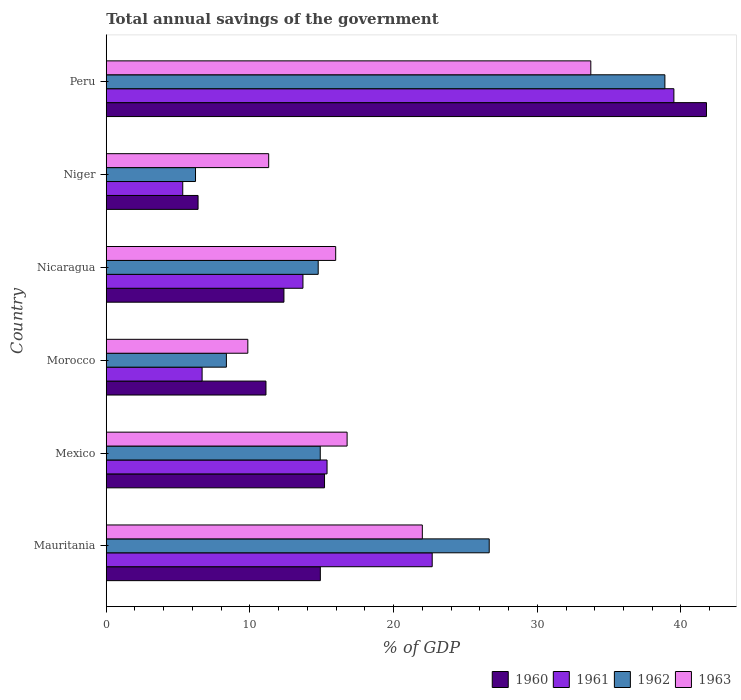Are the number of bars per tick equal to the number of legend labels?
Your response must be concise. Yes. Are the number of bars on each tick of the Y-axis equal?
Provide a short and direct response. Yes. How many bars are there on the 4th tick from the top?
Provide a succinct answer. 4. How many bars are there on the 6th tick from the bottom?
Ensure brevity in your answer.  4. What is the label of the 3rd group of bars from the top?
Offer a very short reply. Nicaragua. What is the total annual savings of the government in 1962 in Niger?
Provide a short and direct response. 6.21. Across all countries, what is the maximum total annual savings of the government in 1960?
Provide a succinct answer. 41.78. Across all countries, what is the minimum total annual savings of the government in 1960?
Provide a short and direct response. 6.39. In which country was the total annual savings of the government in 1963 maximum?
Make the answer very short. Peru. In which country was the total annual savings of the government in 1961 minimum?
Your answer should be very brief. Niger. What is the total total annual savings of the government in 1962 in the graph?
Offer a terse response. 109.76. What is the difference between the total annual savings of the government in 1961 in Morocco and that in Nicaragua?
Your answer should be very brief. -7.02. What is the difference between the total annual savings of the government in 1960 in Niger and the total annual savings of the government in 1963 in Mexico?
Offer a very short reply. -10.37. What is the average total annual savings of the government in 1961 per country?
Provide a succinct answer. 17.21. What is the difference between the total annual savings of the government in 1962 and total annual savings of the government in 1961 in Mexico?
Provide a short and direct response. -0.47. What is the ratio of the total annual savings of the government in 1961 in Mauritania to that in Peru?
Your response must be concise. 0.57. Is the difference between the total annual savings of the government in 1962 in Niger and Peru greater than the difference between the total annual savings of the government in 1961 in Niger and Peru?
Provide a succinct answer. Yes. What is the difference between the highest and the second highest total annual savings of the government in 1963?
Offer a very short reply. 11.73. What is the difference between the highest and the lowest total annual savings of the government in 1960?
Your response must be concise. 35.38. In how many countries, is the total annual savings of the government in 1962 greater than the average total annual savings of the government in 1962 taken over all countries?
Offer a very short reply. 2. Is it the case that in every country, the sum of the total annual savings of the government in 1960 and total annual savings of the government in 1963 is greater than the sum of total annual savings of the government in 1961 and total annual savings of the government in 1962?
Offer a terse response. No. What does the 1st bar from the top in Mexico represents?
Your answer should be very brief. 1963. What does the 2nd bar from the bottom in Peru represents?
Offer a terse response. 1961. Are all the bars in the graph horizontal?
Give a very brief answer. Yes. What is the difference between two consecutive major ticks on the X-axis?
Provide a short and direct response. 10. Are the values on the major ticks of X-axis written in scientific E-notation?
Your answer should be compact. No. Does the graph contain grids?
Make the answer very short. No. How many legend labels are there?
Offer a very short reply. 4. What is the title of the graph?
Offer a terse response. Total annual savings of the government. What is the label or title of the X-axis?
Offer a terse response. % of GDP. What is the % of GDP in 1960 in Mauritania?
Provide a succinct answer. 14.9. What is the % of GDP of 1961 in Mauritania?
Offer a terse response. 22.69. What is the % of GDP in 1962 in Mauritania?
Ensure brevity in your answer.  26.65. What is the % of GDP in 1963 in Mauritania?
Offer a terse response. 22. What is the % of GDP of 1960 in Mexico?
Ensure brevity in your answer.  15.19. What is the % of GDP of 1961 in Mexico?
Your response must be concise. 15.37. What is the % of GDP in 1962 in Mexico?
Give a very brief answer. 14.89. What is the % of GDP in 1963 in Mexico?
Your answer should be very brief. 16.76. What is the % of GDP in 1960 in Morocco?
Offer a terse response. 11.12. What is the % of GDP in 1961 in Morocco?
Your response must be concise. 6.67. What is the % of GDP in 1962 in Morocco?
Give a very brief answer. 8.36. What is the % of GDP in 1963 in Morocco?
Your answer should be compact. 9.85. What is the % of GDP in 1960 in Nicaragua?
Provide a succinct answer. 12.37. What is the % of GDP in 1961 in Nicaragua?
Your answer should be compact. 13.69. What is the % of GDP of 1962 in Nicaragua?
Offer a terse response. 14.75. What is the % of GDP of 1963 in Nicaragua?
Keep it short and to the point. 15.97. What is the % of GDP in 1960 in Niger?
Ensure brevity in your answer.  6.39. What is the % of GDP in 1961 in Niger?
Your answer should be very brief. 5.32. What is the % of GDP of 1962 in Niger?
Your answer should be compact. 6.21. What is the % of GDP of 1963 in Niger?
Keep it short and to the point. 11.31. What is the % of GDP of 1960 in Peru?
Your answer should be compact. 41.78. What is the % of GDP in 1961 in Peru?
Offer a terse response. 39.51. What is the % of GDP in 1962 in Peru?
Provide a short and direct response. 38.88. What is the % of GDP of 1963 in Peru?
Give a very brief answer. 33.73. Across all countries, what is the maximum % of GDP in 1960?
Offer a terse response. 41.78. Across all countries, what is the maximum % of GDP of 1961?
Your answer should be very brief. 39.51. Across all countries, what is the maximum % of GDP of 1962?
Give a very brief answer. 38.88. Across all countries, what is the maximum % of GDP of 1963?
Your response must be concise. 33.73. Across all countries, what is the minimum % of GDP of 1960?
Provide a short and direct response. 6.39. Across all countries, what is the minimum % of GDP of 1961?
Your response must be concise. 5.32. Across all countries, what is the minimum % of GDP of 1962?
Offer a very short reply. 6.21. Across all countries, what is the minimum % of GDP of 1963?
Ensure brevity in your answer.  9.85. What is the total % of GDP in 1960 in the graph?
Provide a short and direct response. 101.74. What is the total % of GDP in 1961 in the graph?
Your answer should be very brief. 103.25. What is the total % of GDP in 1962 in the graph?
Give a very brief answer. 109.76. What is the total % of GDP of 1963 in the graph?
Make the answer very short. 109.62. What is the difference between the % of GDP in 1960 in Mauritania and that in Mexico?
Offer a very short reply. -0.29. What is the difference between the % of GDP of 1961 in Mauritania and that in Mexico?
Your answer should be compact. 7.32. What is the difference between the % of GDP of 1962 in Mauritania and that in Mexico?
Keep it short and to the point. 11.76. What is the difference between the % of GDP in 1963 in Mauritania and that in Mexico?
Your response must be concise. 5.24. What is the difference between the % of GDP of 1960 in Mauritania and that in Morocco?
Your response must be concise. 3.78. What is the difference between the % of GDP of 1961 in Mauritania and that in Morocco?
Give a very brief answer. 16.02. What is the difference between the % of GDP in 1962 in Mauritania and that in Morocco?
Your answer should be very brief. 18.29. What is the difference between the % of GDP of 1963 in Mauritania and that in Morocco?
Keep it short and to the point. 12.14. What is the difference between the % of GDP of 1960 in Mauritania and that in Nicaragua?
Make the answer very short. 2.53. What is the difference between the % of GDP in 1961 in Mauritania and that in Nicaragua?
Make the answer very short. 9. What is the difference between the % of GDP of 1962 in Mauritania and that in Nicaragua?
Your answer should be very brief. 11.9. What is the difference between the % of GDP of 1963 in Mauritania and that in Nicaragua?
Give a very brief answer. 6.03. What is the difference between the % of GDP in 1960 in Mauritania and that in Niger?
Your answer should be compact. 8.51. What is the difference between the % of GDP in 1961 in Mauritania and that in Niger?
Ensure brevity in your answer.  17.36. What is the difference between the % of GDP of 1962 in Mauritania and that in Niger?
Offer a very short reply. 20.44. What is the difference between the % of GDP of 1963 in Mauritania and that in Niger?
Ensure brevity in your answer.  10.69. What is the difference between the % of GDP of 1960 in Mauritania and that in Peru?
Provide a succinct answer. -26.88. What is the difference between the % of GDP of 1961 in Mauritania and that in Peru?
Provide a succinct answer. -16.82. What is the difference between the % of GDP in 1962 in Mauritania and that in Peru?
Provide a succinct answer. -12.23. What is the difference between the % of GDP in 1963 in Mauritania and that in Peru?
Your response must be concise. -11.73. What is the difference between the % of GDP in 1960 in Mexico and that in Morocco?
Your response must be concise. 4.08. What is the difference between the % of GDP in 1961 in Mexico and that in Morocco?
Offer a terse response. 8.7. What is the difference between the % of GDP of 1962 in Mexico and that in Morocco?
Provide a succinct answer. 6.53. What is the difference between the % of GDP of 1963 in Mexico and that in Morocco?
Offer a terse response. 6.91. What is the difference between the % of GDP in 1960 in Mexico and that in Nicaragua?
Provide a short and direct response. 2.82. What is the difference between the % of GDP of 1961 in Mexico and that in Nicaragua?
Make the answer very short. 1.68. What is the difference between the % of GDP in 1962 in Mexico and that in Nicaragua?
Keep it short and to the point. 0.14. What is the difference between the % of GDP in 1963 in Mexico and that in Nicaragua?
Make the answer very short. 0.8. What is the difference between the % of GDP of 1960 in Mexico and that in Niger?
Provide a short and direct response. 8.8. What is the difference between the % of GDP of 1961 in Mexico and that in Niger?
Make the answer very short. 10.04. What is the difference between the % of GDP of 1962 in Mexico and that in Niger?
Give a very brief answer. 8.68. What is the difference between the % of GDP in 1963 in Mexico and that in Niger?
Your answer should be very brief. 5.46. What is the difference between the % of GDP in 1960 in Mexico and that in Peru?
Give a very brief answer. -26.58. What is the difference between the % of GDP in 1961 in Mexico and that in Peru?
Provide a succinct answer. -24.14. What is the difference between the % of GDP of 1962 in Mexico and that in Peru?
Your response must be concise. -23.99. What is the difference between the % of GDP in 1963 in Mexico and that in Peru?
Provide a short and direct response. -16.96. What is the difference between the % of GDP of 1960 in Morocco and that in Nicaragua?
Your answer should be very brief. -1.25. What is the difference between the % of GDP in 1961 in Morocco and that in Nicaragua?
Your response must be concise. -7.02. What is the difference between the % of GDP of 1962 in Morocco and that in Nicaragua?
Your answer should be very brief. -6.39. What is the difference between the % of GDP in 1963 in Morocco and that in Nicaragua?
Keep it short and to the point. -6.11. What is the difference between the % of GDP in 1960 in Morocco and that in Niger?
Make the answer very short. 4.73. What is the difference between the % of GDP of 1961 in Morocco and that in Niger?
Make the answer very short. 1.35. What is the difference between the % of GDP in 1962 in Morocco and that in Niger?
Offer a very short reply. 2.15. What is the difference between the % of GDP in 1963 in Morocco and that in Niger?
Ensure brevity in your answer.  -1.45. What is the difference between the % of GDP of 1960 in Morocco and that in Peru?
Your response must be concise. -30.66. What is the difference between the % of GDP in 1961 in Morocco and that in Peru?
Your answer should be very brief. -32.84. What is the difference between the % of GDP of 1962 in Morocco and that in Peru?
Provide a short and direct response. -30.52. What is the difference between the % of GDP in 1963 in Morocco and that in Peru?
Make the answer very short. -23.87. What is the difference between the % of GDP in 1960 in Nicaragua and that in Niger?
Ensure brevity in your answer.  5.98. What is the difference between the % of GDP of 1961 in Nicaragua and that in Niger?
Make the answer very short. 8.37. What is the difference between the % of GDP in 1962 in Nicaragua and that in Niger?
Make the answer very short. 8.54. What is the difference between the % of GDP in 1963 in Nicaragua and that in Niger?
Ensure brevity in your answer.  4.66. What is the difference between the % of GDP in 1960 in Nicaragua and that in Peru?
Make the answer very short. -29.41. What is the difference between the % of GDP in 1961 in Nicaragua and that in Peru?
Provide a short and direct response. -25.82. What is the difference between the % of GDP in 1962 in Nicaragua and that in Peru?
Give a very brief answer. -24.13. What is the difference between the % of GDP in 1963 in Nicaragua and that in Peru?
Offer a very short reply. -17.76. What is the difference between the % of GDP of 1960 in Niger and that in Peru?
Provide a short and direct response. -35.38. What is the difference between the % of GDP in 1961 in Niger and that in Peru?
Offer a terse response. -34.18. What is the difference between the % of GDP of 1962 in Niger and that in Peru?
Your answer should be compact. -32.67. What is the difference between the % of GDP in 1963 in Niger and that in Peru?
Your answer should be compact. -22.42. What is the difference between the % of GDP in 1960 in Mauritania and the % of GDP in 1961 in Mexico?
Keep it short and to the point. -0.47. What is the difference between the % of GDP in 1960 in Mauritania and the % of GDP in 1962 in Mexico?
Offer a very short reply. 0.01. What is the difference between the % of GDP in 1960 in Mauritania and the % of GDP in 1963 in Mexico?
Ensure brevity in your answer.  -1.86. What is the difference between the % of GDP of 1961 in Mauritania and the % of GDP of 1962 in Mexico?
Ensure brevity in your answer.  7.79. What is the difference between the % of GDP of 1961 in Mauritania and the % of GDP of 1963 in Mexico?
Ensure brevity in your answer.  5.92. What is the difference between the % of GDP in 1962 in Mauritania and the % of GDP in 1963 in Mexico?
Provide a short and direct response. 9.89. What is the difference between the % of GDP in 1960 in Mauritania and the % of GDP in 1961 in Morocco?
Ensure brevity in your answer.  8.23. What is the difference between the % of GDP in 1960 in Mauritania and the % of GDP in 1962 in Morocco?
Your response must be concise. 6.54. What is the difference between the % of GDP in 1960 in Mauritania and the % of GDP in 1963 in Morocco?
Your answer should be very brief. 5.05. What is the difference between the % of GDP of 1961 in Mauritania and the % of GDP of 1962 in Morocco?
Your response must be concise. 14.32. What is the difference between the % of GDP in 1961 in Mauritania and the % of GDP in 1963 in Morocco?
Provide a short and direct response. 12.83. What is the difference between the % of GDP in 1962 in Mauritania and the % of GDP in 1963 in Morocco?
Offer a terse response. 16.8. What is the difference between the % of GDP of 1960 in Mauritania and the % of GDP of 1961 in Nicaragua?
Keep it short and to the point. 1.21. What is the difference between the % of GDP of 1960 in Mauritania and the % of GDP of 1962 in Nicaragua?
Give a very brief answer. 0.15. What is the difference between the % of GDP in 1960 in Mauritania and the % of GDP in 1963 in Nicaragua?
Keep it short and to the point. -1.07. What is the difference between the % of GDP of 1961 in Mauritania and the % of GDP of 1962 in Nicaragua?
Give a very brief answer. 7.93. What is the difference between the % of GDP in 1961 in Mauritania and the % of GDP in 1963 in Nicaragua?
Your response must be concise. 6.72. What is the difference between the % of GDP of 1962 in Mauritania and the % of GDP of 1963 in Nicaragua?
Give a very brief answer. 10.69. What is the difference between the % of GDP of 1960 in Mauritania and the % of GDP of 1961 in Niger?
Provide a succinct answer. 9.58. What is the difference between the % of GDP in 1960 in Mauritania and the % of GDP in 1962 in Niger?
Provide a succinct answer. 8.69. What is the difference between the % of GDP in 1960 in Mauritania and the % of GDP in 1963 in Niger?
Offer a very short reply. 3.6. What is the difference between the % of GDP of 1961 in Mauritania and the % of GDP of 1962 in Niger?
Your answer should be very brief. 16.47. What is the difference between the % of GDP of 1961 in Mauritania and the % of GDP of 1963 in Niger?
Offer a very short reply. 11.38. What is the difference between the % of GDP of 1962 in Mauritania and the % of GDP of 1963 in Niger?
Offer a very short reply. 15.35. What is the difference between the % of GDP of 1960 in Mauritania and the % of GDP of 1961 in Peru?
Your answer should be compact. -24.61. What is the difference between the % of GDP of 1960 in Mauritania and the % of GDP of 1962 in Peru?
Your answer should be compact. -23.98. What is the difference between the % of GDP of 1960 in Mauritania and the % of GDP of 1963 in Peru?
Make the answer very short. -18.83. What is the difference between the % of GDP in 1961 in Mauritania and the % of GDP in 1962 in Peru?
Your answer should be compact. -16.19. What is the difference between the % of GDP of 1961 in Mauritania and the % of GDP of 1963 in Peru?
Your answer should be very brief. -11.04. What is the difference between the % of GDP in 1962 in Mauritania and the % of GDP in 1963 in Peru?
Offer a very short reply. -7.07. What is the difference between the % of GDP of 1960 in Mexico and the % of GDP of 1961 in Morocco?
Keep it short and to the point. 8.52. What is the difference between the % of GDP in 1960 in Mexico and the % of GDP in 1962 in Morocco?
Offer a very short reply. 6.83. What is the difference between the % of GDP in 1960 in Mexico and the % of GDP in 1963 in Morocco?
Offer a very short reply. 5.34. What is the difference between the % of GDP of 1961 in Mexico and the % of GDP of 1962 in Morocco?
Your response must be concise. 7.01. What is the difference between the % of GDP in 1961 in Mexico and the % of GDP in 1963 in Morocco?
Your answer should be very brief. 5.51. What is the difference between the % of GDP of 1962 in Mexico and the % of GDP of 1963 in Morocco?
Your answer should be very brief. 5.04. What is the difference between the % of GDP in 1960 in Mexico and the % of GDP in 1961 in Nicaragua?
Provide a succinct answer. 1.5. What is the difference between the % of GDP in 1960 in Mexico and the % of GDP in 1962 in Nicaragua?
Provide a short and direct response. 0.44. What is the difference between the % of GDP of 1960 in Mexico and the % of GDP of 1963 in Nicaragua?
Ensure brevity in your answer.  -0.78. What is the difference between the % of GDP in 1961 in Mexico and the % of GDP in 1962 in Nicaragua?
Keep it short and to the point. 0.62. What is the difference between the % of GDP of 1961 in Mexico and the % of GDP of 1963 in Nicaragua?
Your response must be concise. -0.6. What is the difference between the % of GDP of 1962 in Mexico and the % of GDP of 1963 in Nicaragua?
Your response must be concise. -1.07. What is the difference between the % of GDP in 1960 in Mexico and the % of GDP in 1961 in Niger?
Your answer should be compact. 9.87. What is the difference between the % of GDP of 1960 in Mexico and the % of GDP of 1962 in Niger?
Give a very brief answer. 8.98. What is the difference between the % of GDP of 1960 in Mexico and the % of GDP of 1963 in Niger?
Your answer should be compact. 3.89. What is the difference between the % of GDP in 1961 in Mexico and the % of GDP in 1962 in Niger?
Provide a short and direct response. 9.16. What is the difference between the % of GDP in 1961 in Mexico and the % of GDP in 1963 in Niger?
Give a very brief answer. 4.06. What is the difference between the % of GDP in 1962 in Mexico and the % of GDP in 1963 in Niger?
Give a very brief answer. 3.59. What is the difference between the % of GDP of 1960 in Mexico and the % of GDP of 1961 in Peru?
Make the answer very short. -24.32. What is the difference between the % of GDP in 1960 in Mexico and the % of GDP in 1962 in Peru?
Offer a terse response. -23.69. What is the difference between the % of GDP in 1960 in Mexico and the % of GDP in 1963 in Peru?
Give a very brief answer. -18.53. What is the difference between the % of GDP of 1961 in Mexico and the % of GDP of 1962 in Peru?
Keep it short and to the point. -23.51. What is the difference between the % of GDP in 1961 in Mexico and the % of GDP in 1963 in Peru?
Your answer should be very brief. -18.36. What is the difference between the % of GDP in 1962 in Mexico and the % of GDP in 1963 in Peru?
Offer a very short reply. -18.83. What is the difference between the % of GDP of 1960 in Morocco and the % of GDP of 1961 in Nicaragua?
Offer a terse response. -2.57. What is the difference between the % of GDP in 1960 in Morocco and the % of GDP in 1962 in Nicaragua?
Keep it short and to the point. -3.63. What is the difference between the % of GDP of 1960 in Morocco and the % of GDP of 1963 in Nicaragua?
Your answer should be compact. -4.85. What is the difference between the % of GDP in 1961 in Morocco and the % of GDP in 1962 in Nicaragua?
Your response must be concise. -8.08. What is the difference between the % of GDP in 1961 in Morocco and the % of GDP in 1963 in Nicaragua?
Keep it short and to the point. -9.3. What is the difference between the % of GDP of 1962 in Morocco and the % of GDP of 1963 in Nicaragua?
Provide a short and direct response. -7.61. What is the difference between the % of GDP of 1960 in Morocco and the % of GDP of 1961 in Niger?
Your answer should be compact. 5.79. What is the difference between the % of GDP of 1960 in Morocco and the % of GDP of 1962 in Niger?
Your answer should be compact. 4.9. What is the difference between the % of GDP of 1960 in Morocco and the % of GDP of 1963 in Niger?
Make the answer very short. -0.19. What is the difference between the % of GDP in 1961 in Morocco and the % of GDP in 1962 in Niger?
Your answer should be very brief. 0.46. What is the difference between the % of GDP in 1961 in Morocco and the % of GDP in 1963 in Niger?
Your answer should be very brief. -4.63. What is the difference between the % of GDP of 1962 in Morocco and the % of GDP of 1963 in Niger?
Provide a short and direct response. -2.94. What is the difference between the % of GDP in 1960 in Morocco and the % of GDP in 1961 in Peru?
Provide a short and direct response. -28.39. What is the difference between the % of GDP in 1960 in Morocco and the % of GDP in 1962 in Peru?
Make the answer very short. -27.76. What is the difference between the % of GDP of 1960 in Morocco and the % of GDP of 1963 in Peru?
Keep it short and to the point. -22.61. What is the difference between the % of GDP in 1961 in Morocco and the % of GDP in 1962 in Peru?
Offer a very short reply. -32.21. What is the difference between the % of GDP in 1961 in Morocco and the % of GDP in 1963 in Peru?
Your answer should be compact. -27.05. What is the difference between the % of GDP of 1962 in Morocco and the % of GDP of 1963 in Peru?
Give a very brief answer. -25.36. What is the difference between the % of GDP of 1960 in Nicaragua and the % of GDP of 1961 in Niger?
Your answer should be compact. 7.04. What is the difference between the % of GDP of 1960 in Nicaragua and the % of GDP of 1962 in Niger?
Your answer should be very brief. 6.16. What is the difference between the % of GDP in 1960 in Nicaragua and the % of GDP in 1963 in Niger?
Your answer should be very brief. 1.06. What is the difference between the % of GDP of 1961 in Nicaragua and the % of GDP of 1962 in Niger?
Provide a short and direct response. 7.48. What is the difference between the % of GDP of 1961 in Nicaragua and the % of GDP of 1963 in Niger?
Keep it short and to the point. 2.38. What is the difference between the % of GDP in 1962 in Nicaragua and the % of GDP in 1963 in Niger?
Ensure brevity in your answer.  3.45. What is the difference between the % of GDP in 1960 in Nicaragua and the % of GDP in 1961 in Peru?
Offer a terse response. -27.14. What is the difference between the % of GDP in 1960 in Nicaragua and the % of GDP in 1962 in Peru?
Offer a very short reply. -26.51. What is the difference between the % of GDP of 1960 in Nicaragua and the % of GDP of 1963 in Peru?
Make the answer very short. -21.36. What is the difference between the % of GDP in 1961 in Nicaragua and the % of GDP in 1962 in Peru?
Your response must be concise. -25.19. What is the difference between the % of GDP of 1961 in Nicaragua and the % of GDP of 1963 in Peru?
Your response must be concise. -20.04. What is the difference between the % of GDP of 1962 in Nicaragua and the % of GDP of 1963 in Peru?
Provide a succinct answer. -18.97. What is the difference between the % of GDP of 1960 in Niger and the % of GDP of 1961 in Peru?
Offer a very short reply. -33.12. What is the difference between the % of GDP in 1960 in Niger and the % of GDP in 1962 in Peru?
Make the answer very short. -32.49. What is the difference between the % of GDP in 1960 in Niger and the % of GDP in 1963 in Peru?
Provide a succinct answer. -27.33. What is the difference between the % of GDP of 1961 in Niger and the % of GDP of 1962 in Peru?
Your answer should be compact. -33.56. What is the difference between the % of GDP in 1961 in Niger and the % of GDP in 1963 in Peru?
Ensure brevity in your answer.  -28.4. What is the difference between the % of GDP of 1962 in Niger and the % of GDP of 1963 in Peru?
Your response must be concise. -27.51. What is the average % of GDP of 1960 per country?
Your answer should be very brief. 16.96. What is the average % of GDP of 1961 per country?
Keep it short and to the point. 17.21. What is the average % of GDP in 1962 per country?
Ensure brevity in your answer.  18.29. What is the average % of GDP of 1963 per country?
Ensure brevity in your answer.  18.27. What is the difference between the % of GDP of 1960 and % of GDP of 1961 in Mauritania?
Your answer should be very brief. -7.79. What is the difference between the % of GDP in 1960 and % of GDP in 1962 in Mauritania?
Offer a very short reply. -11.75. What is the difference between the % of GDP in 1960 and % of GDP in 1963 in Mauritania?
Give a very brief answer. -7.1. What is the difference between the % of GDP in 1961 and % of GDP in 1962 in Mauritania?
Provide a succinct answer. -3.97. What is the difference between the % of GDP in 1961 and % of GDP in 1963 in Mauritania?
Keep it short and to the point. 0.69. What is the difference between the % of GDP in 1962 and % of GDP in 1963 in Mauritania?
Offer a terse response. 4.66. What is the difference between the % of GDP of 1960 and % of GDP of 1961 in Mexico?
Offer a very short reply. -0.18. What is the difference between the % of GDP of 1960 and % of GDP of 1962 in Mexico?
Keep it short and to the point. 0.3. What is the difference between the % of GDP in 1960 and % of GDP in 1963 in Mexico?
Offer a very short reply. -1.57. What is the difference between the % of GDP of 1961 and % of GDP of 1962 in Mexico?
Your answer should be compact. 0.47. What is the difference between the % of GDP in 1961 and % of GDP in 1963 in Mexico?
Your answer should be compact. -1.4. What is the difference between the % of GDP of 1962 and % of GDP of 1963 in Mexico?
Your answer should be very brief. -1.87. What is the difference between the % of GDP in 1960 and % of GDP in 1961 in Morocco?
Ensure brevity in your answer.  4.45. What is the difference between the % of GDP of 1960 and % of GDP of 1962 in Morocco?
Provide a short and direct response. 2.75. What is the difference between the % of GDP in 1960 and % of GDP in 1963 in Morocco?
Make the answer very short. 1.26. What is the difference between the % of GDP of 1961 and % of GDP of 1962 in Morocco?
Make the answer very short. -1.69. What is the difference between the % of GDP in 1961 and % of GDP in 1963 in Morocco?
Your answer should be compact. -3.18. What is the difference between the % of GDP of 1962 and % of GDP of 1963 in Morocco?
Your answer should be compact. -1.49. What is the difference between the % of GDP in 1960 and % of GDP in 1961 in Nicaragua?
Keep it short and to the point. -1.32. What is the difference between the % of GDP of 1960 and % of GDP of 1962 in Nicaragua?
Provide a succinct answer. -2.38. What is the difference between the % of GDP of 1960 and % of GDP of 1963 in Nicaragua?
Keep it short and to the point. -3.6. What is the difference between the % of GDP in 1961 and % of GDP in 1962 in Nicaragua?
Your response must be concise. -1.06. What is the difference between the % of GDP in 1961 and % of GDP in 1963 in Nicaragua?
Keep it short and to the point. -2.28. What is the difference between the % of GDP of 1962 and % of GDP of 1963 in Nicaragua?
Provide a short and direct response. -1.22. What is the difference between the % of GDP of 1960 and % of GDP of 1961 in Niger?
Offer a very short reply. 1.07. What is the difference between the % of GDP in 1960 and % of GDP in 1962 in Niger?
Give a very brief answer. 0.18. What is the difference between the % of GDP in 1960 and % of GDP in 1963 in Niger?
Offer a very short reply. -4.91. What is the difference between the % of GDP in 1961 and % of GDP in 1962 in Niger?
Your answer should be compact. -0.89. What is the difference between the % of GDP in 1961 and % of GDP in 1963 in Niger?
Provide a succinct answer. -5.98. What is the difference between the % of GDP in 1962 and % of GDP in 1963 in Niger?
Your answer should be compact. -5.09. What is the difference between the % of GDP of 1960 and % of GDP of 1961 in Peru?
Your answer should be very brief. 2.27. What is the difference between the % of GDP of 1960 and % of GDP of 1962 in Peru?
Make the answer very short. 2.89. What is the difference between the % of GDP in 1960 and % of GDP in 1963 in Peru?
Provide a short and direct response. 8.05. What is the difference between the % of GDP in 1961 and % of GDP in 1962 in Peru?
Offer a terse response. 0.63. What is the difference between the % of GDP in 1961 and % of GDP in 1963 in Peru?
Offer a very short reply. 5.78. What is the difference between the % of GDP of 1962 and % of GDP of 1963 in Peru?
Keep it short and to the point. 5.16. What is the ratio of the % of GDP in 1960 in Mauritania to that in Mexico?
Provide a succinct answer. 0.98. What is the ratio of the % of GDP of 1961 in Mauritania to that in Mexico?
Ensure brevity in your answer.  1.48. What is the ratio of the % of GDP in 1962 in Mauritania to that in Mexico?
Provide a succinct answer. 1.79. What is the ratio of the % of GDP of 1963 in Mauritania to that in Mexico?
Make the answer very short. 1.31. What is the ratio of the % of GDP of 1960 in Mauritania to that in Morocco?
Offer a very short reply. 1.34. What is the ratio of the % of GDP in 1961 in Mauritania to that in Morocco?
Offer a terse response. 3.4. What is the ratio of the % of GDP in 1962 in Mauritania to that in Morocco?
Offer a terse response. 3.19. What is the ratio of the % of GDP in 1963 in Mauritania to that in Morocco?
Provide a succinct answer. 2.23. What is the ratio of the % of GDP in 1960 in Mauritania to that in Nicaragua?
Offer a very short reply. 1.2. What is the ratio of the % of GDP in 1961 in Mauritania to that in Nicaragua?
Your answer should be very brief. 1.66. What is the ratio of the % of GDP of 1962 in Mauritania to that in Nicaragua?
Give a very brief answer. 1.81. What is the ratio of the % of GDP in 1963 in Mauritania to that in Nicaragua?
Make the answer very short. 1.38. What is the ratio of the % of GDP of 1960 in Mauritania to that in Niger?
Offer a terse response. 2.33. What is the ratio of the % of GDP of 1961 in Mauritania to that in Niger?
Your response must be concise. 4.26. What is the ratio of the % of GDP in 1962 in Mauritania to that in Niger?
Your answer should be compact. 4.29. What is the ratio of the % of GDP of 1963 in Mauritania to that in Niger?
Make the answer very short. 1.95. What is the ratio of the % of GDP in 1960 in Mauritania to that in Peru?
Your response must be concise. 0.36. What is the ratio of the % of GDP of 1961 in Mauritania to that in Peru?
Your answer should be very brief. 0.57. What is the ratio of the % of GDP of 1962 in Mauritania to that in Peru?
Your response must be concise. 0.69. What is the ratio of the % of GDP in 1963 in Mauritania to that in Peru?
Offer a very short reply. 0.65. What is the ratio of the % of GDP of 1960 in Mexico to that in Morocco?
Your answer should be compact. 1.37. What is the ratio of the % of GDP in 1961 in Mexico to that in Morocco?
Your answer should be compact. 2.3. What is the ratio of the % of GDP in 1962 in Mexico to that in Morocco?
Provide a succinct answer. 1.78. What is the ratio of the % of GDP of 1963 in Mexico to that in Morocco?
Offer a terse response. 1.7. What is the ratio of the % of GDP of 1960 in Mexico to that in Nicaragua?
Offer a very short reply. 1.23. What is the ratio of the % of GDP of 1961 in Mexico to that in Nicaragua?
Keep it short and to the point. 1.12. What is the ratio of the % of GDP of 1962 in Mexico to that in Nicaragua?
Provide a succinct answer. 1.01. What is the ratio of the % of GDP in 1963 in Mexico to that in Nicaragua?
Your response must be concise. 1.05. What is the ratio of the % of GDP of 1960 in Mexico to that in Niger?
Make the answer very short. 2.38. What is the ratio of the % of GDP in 1961 in Mexico to that in Niger?
Offer a terse response. 2.89. What is the ratio of the % of GDP in 1962 in Mexico to that in Niger?
Keep it short and to the point. 2.4. What is the ratio of the % of GDP of 1963 in Mexico to that in Niger?
Ensure brevity in your answer.  1.48. What is the ratio of the % of GDP of 1960 in Mexico to that in Peru?
Provide a succinct answer. 0.36. What is the ratio of the % of GDP in 1961 in Mexico to that in Peru?
Offer a very short reply. 0.39. What is the ratio of the % of GDP of 1962 in Mexico to that in Peru?
Your answer should be very brief. 0.38. What is the ratio of the % of GDP of 1963 in Mexico to that in Peru?
Offer a terse response. 0.5. What is the ratio of the % of GDP of 1960 in Morocco to that in Nicaragua?
Provide a short and direct response. 0.9. What is the ratio of the % of GDP of 1961 in Morocco to that in Nicaragua?
Provide a short and direct response. 0.49. What is the ratio of the % of GDP of 1962 in Morocco to that in Nicaragua?
Offer a very short reply. 0.57. What is the ratio of the % of GDP in 1963 in Morocco to that in Nicaragua?
Provide a short and direct response. 0.62. What is the ratio of the % of GDP of 1960 in Morocco to that in Niger?
Offer a very short reply. 1.74. What is the ratio of the % of GDP in 1961 in Morocco to that in Niger?
Offer a terse response. 1.25. What is the ratio of the % of GDP of 1962 in Morocco to that in Niger?
Keep it short and to the point. 1.35. What is the ratio of the % of GDP in 1963 in Morocco to that in Niger?
Keep it short and to the point. 0.87. What is the ratio of the % of GDP of 1960 in Morocco to that in Peru?
Your answer should be very brief. 0.27. What is the ratio of the % of GDP in 1961 in Morocco to that in Peru?
Provide a short and direct response. 0.17. What is the ratio of the % of GDP in 1962 in Morocco to that in Peru?
Your response must be concise. 0.22. What is the ratio of the % of GDP in 1963 in Morocco to that in Peru?
Provide a succinct answer. 0.29. What is the ratio of the % of GDP of 1960 in Nicaragua to that in Niger?
Give a very brief answer. 1.94. What is the ratio of the % of GDP of 1961 in Nicaragua to that in Niger?
Offer a terse response. 2.57. What is the ratio of the % of GDP of 1962 in Nicaragua to that in Niger?
Offer a terse response. 2.37. What is the ratio of the % of GDP of 1963 in Nicaragua to that in Niger?
Offer a terse response. 1.41. What is the ratio of the % of GDP in 1960 in Nicaragua to that in Peru?
Keep it short and to the point. 0.3. What is the ratio of the % of GDP in 1961 in Nicaragua to that in Peru?
Make the answer very short. 0.35. What is the ratio of the % of GDP in 1962 in Nicaragua to that in Peru?
Provide a short and direct response. 0.38. What is the ratio of the % of GDP of 1963 in Nicaragua to that in Peru?
Provide a succinct answer. 0.47. What is the ratio of the % of GDP of 1960 in Niger to that in Peru?
Offer a very short reply. 0.15. What is the ratio of the % of GDP in 1961 in Niger to that in Peru?
Ensure brevity in your answer.  0.13. What is the ratio of the % of GDP of 1962 in Niger to that in Peru?
Give a very brief answer. 0.16. What is the ratio of the % of GDP in 1963 in Niger to that in Peru?
Give a very brief answer. 0.34. What is the difference between the highest and the second highest % of GDP of 1960?
Give a very brief answer. 26.58. What is the difference between the highest and the second highest % of GDP in 1961?
Offer a terse response. 16.82. What is the difference between the highest and the second highest % of GDP of 1962?
Your response must be concise. 12.23. What is the difference between the highest and the second highest % of GDP in 1963?
Offer a terse response. 11.73. What is the difference between the highest and the lowest % of GDP of 1960?
Make the answer very short. 35.38. What is the difference between the highest and the lowest % of GDP in 1961?
Your answer should be compact. 34.18. What is the difference between the highest and the lowest % of GDP of 1962?
Make the answer very short. 32.67. What is the difference between the highest and the lowest % of GDP of 1963?
Your answer should be compact. 23.87. 